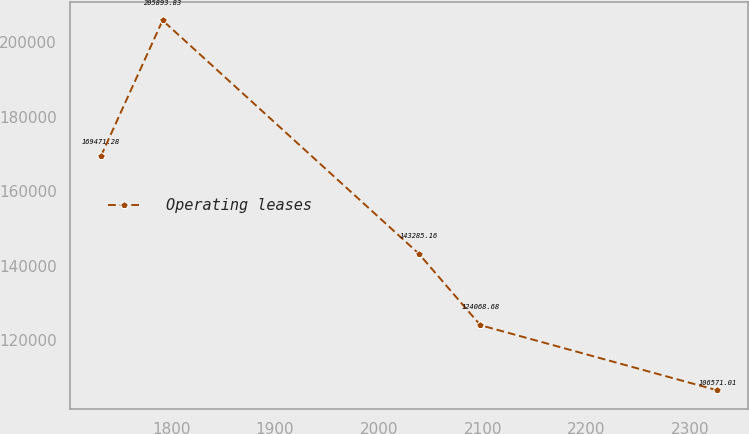<chart> <loc_0><loc_0><loc_500><loc_500><line_chart><ecel><fcel>Operating leases<nl><fcel>1732.21<fcel>169471<nl><fcel>1791.6<fcel>205894<nl><fcel>2038.41<fcel>143285<nl><fcel>2097.8<fcel>124069<nl><fcel>2326.13<fcel>106571<nl></chart> 